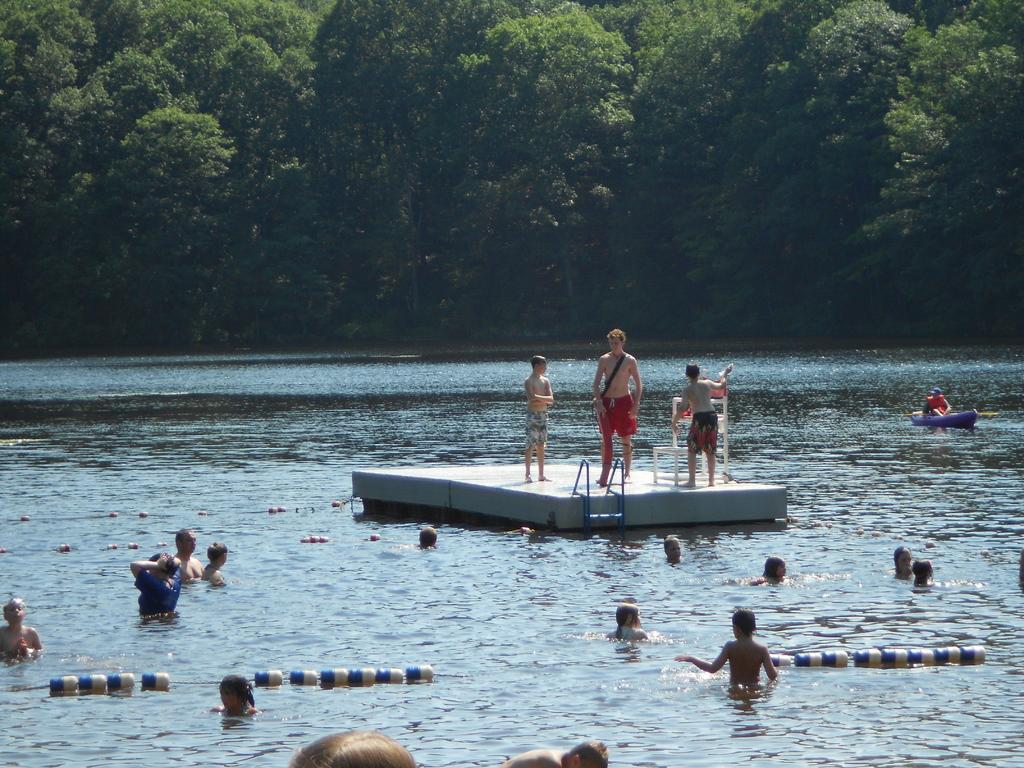Could you give a brief overview of what you see in this image? In the image there is a river and there are a lot of people swimming in the river water and at the center there is some object, on that there are three people standing and in the background there are a lot of trees. 